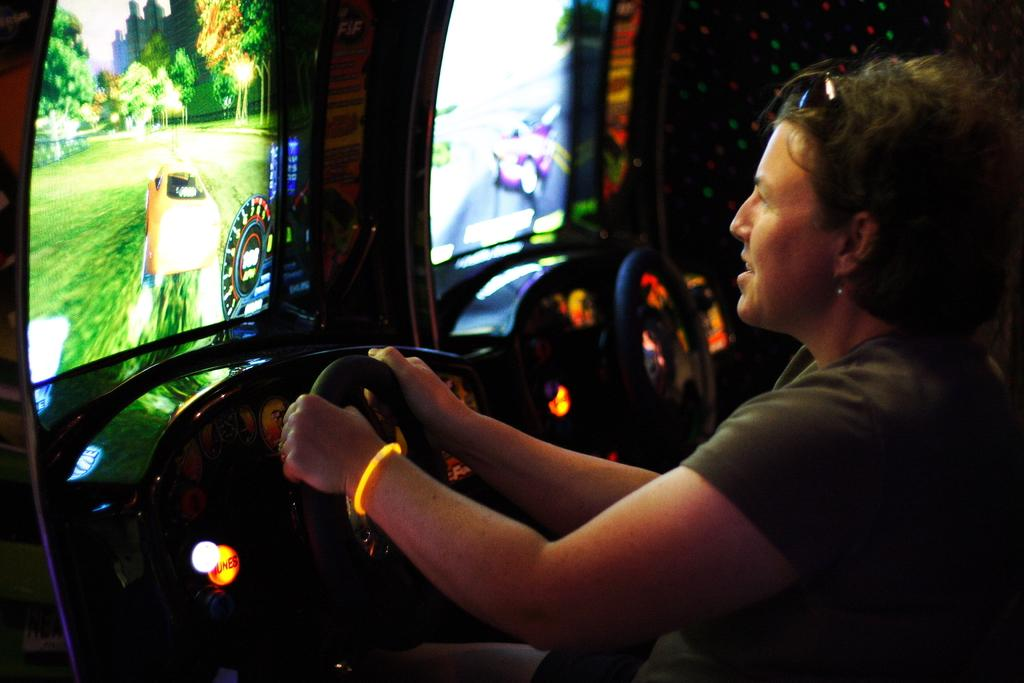Who is the main subject in the image? There is a woman in the image. What is the woman doing in the image? The woman is holding the steering wheel with her hand. What can be seen on the screens in the image? The details of the screens are not mentioned, but they are visible in the image. What type of illumination is present in the image? There are lights present in the image. What time of day is it in the image, considering the presence of the afternoon? The time of day is not mentioned in the facts, and there is no indication of the afternoon in the image. 